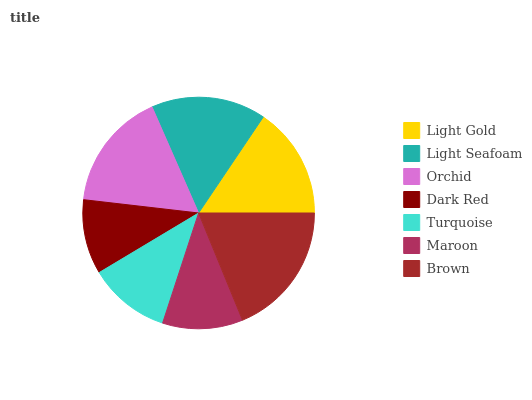Is Dark Red the minimum?
Answer yes or no. Yes. Is Brown the maximum?
Answer yes or no. Yes. Is Light Seafoam the minimum?
Answer yes or no. No. Is Light Seafoam the maximum?
Answer yes or no. No. Is Light Seafoam greater than Light Gold?
Answer yes or no. Yes. Is Light Gold less than Light Seafoam?
Answer yes or no. Yes. Is Light Gold greater than Light Seafoam?
Answer yes or no. No. Is Light Seafoam less than Light Gold?
Answer yes or no. No. Is Light Gold the high median?
Answer yes or no. Yes. Is Light Gold the low median?
Answer yes or no. Yes. Is Turquoise the high median?
Answer yes or no. No. Is Dark Red the low median?
Answer yes or no. No. 